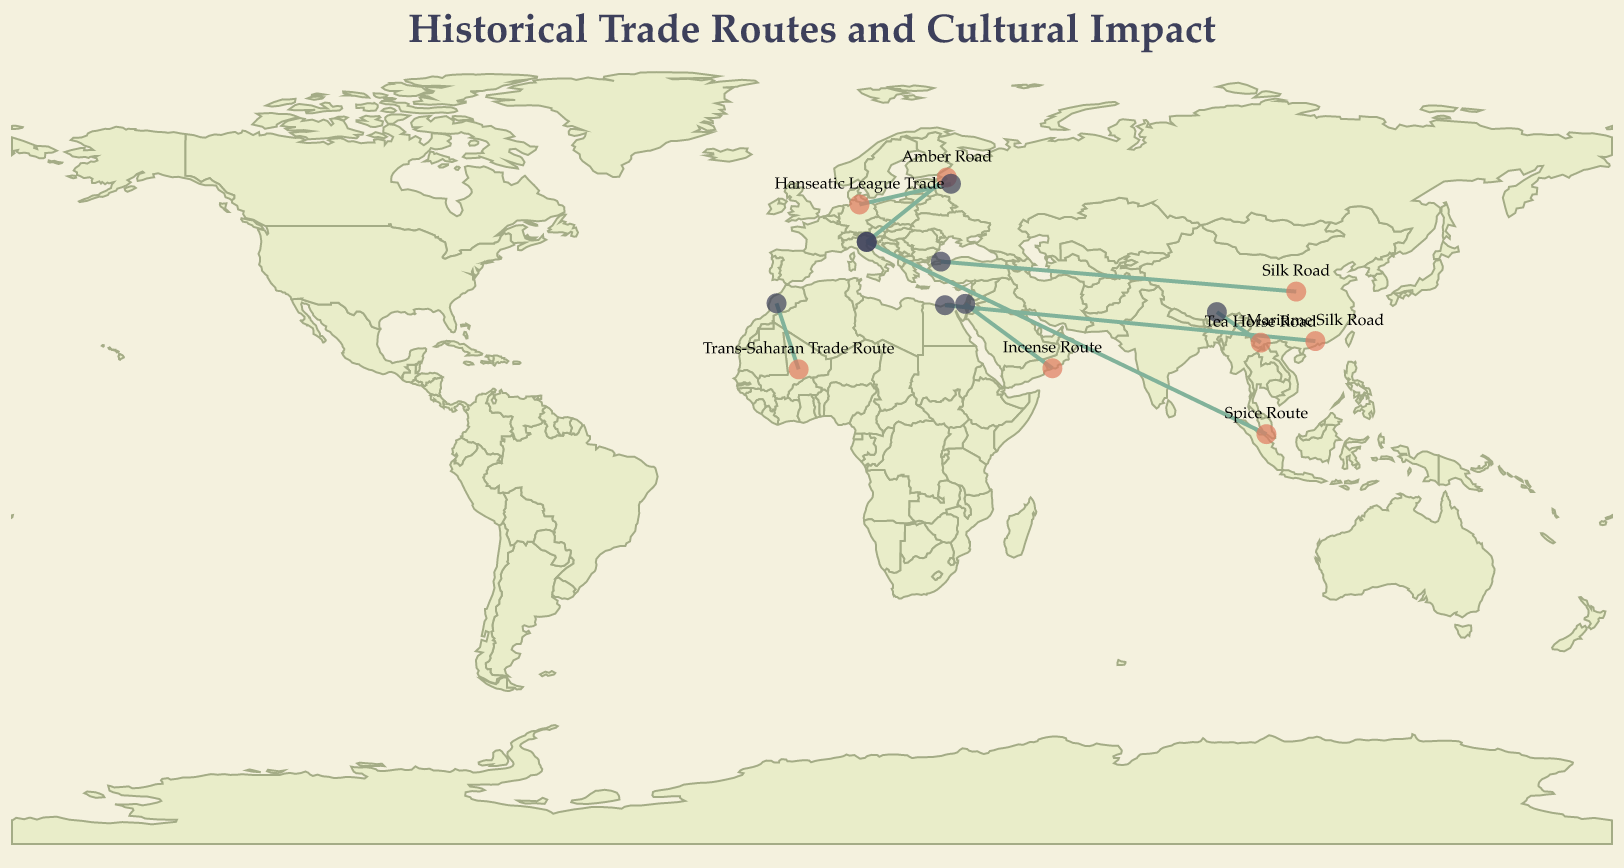What is the title of the figure? The title is prominently displayed at the top of the figure, which helps to understand the overall theme.
Answer: Historical Trade Routes and Cultural Impact How many historical trade routes are shown in the figure? Each trade route is represented by a different rule line connecting two geographical points. By counting these lines, you can determine the total number of routes.
Answer: 8 Which trade route has the highest cultural impact? By referring to the tooltip information, you can identify the value of "Cultural Impact" for each route and find which one is the highest.
Answer: Spice Route and Maritime Silk Road (both have 8) Which trade route begins in Lübeck? The starting point of each trade route is marked by a circle, and the tooltip can help confirm the associated route. The route starting in Lübeck is labeled in the tooltip information.
Answer: Hanseatic League Trade What is the geographical range of the Trans-Saharan Trade Route? By looking at the tooltip information for the Trans-Saharan Trade Route, you can identify the starting and ending cities, and their respective coordinates.
Answer: Timbuktu to Marrakesh Compare the starting latitude of the Silk Road and the Tea Horse Road. Which is higher? By comparing the latitude values in the tooltip for the starting points of each route, you can determine which latitude is higher.
Answer: Silk Road How many trade routes started in Asian regions? Identify the trade routes with starting points in Asian cities by referring to the latitude and longitude coordinates combined with their name. Count the total number of these routes.
Answer: 5 Which route spans the longest east-to-west distance? By comparing the longitudes of the start and end points of each route, the difference between these can be calculated, and then the greatest difference can be determined.
Answer: Spice Route What is the average cultural impact across all the shown trade routes? Sum the cultural impact values for all the routes and divide by the total number of routes to find the average.
Answer: (7+8+6+7+5+6+8+7)/8 = 6.75 How many routes terminated in Venice, and what were their cultural impacts? Identify the trade routes that ended in Venice by looking at the tooltip information for the end points. Record their cultural impacts.
Answer: Two routes (Spice Route and Amber Road) with cultural impacts of 8 and 6 respectively 